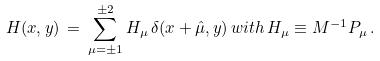<formula> <loc_0><loc_0><loc_500><loc_500>H ( x , y ) \, = \, \sum _ { \mu = \pm 1 } ^ { \pm 2 } H _ { \mu } \, \delta ( x + \hat { \mu } , y ) \, w i t h \, H _ { \mu } \equiv M ^ { - 1 } P _ { \mu } \, .</formula> 